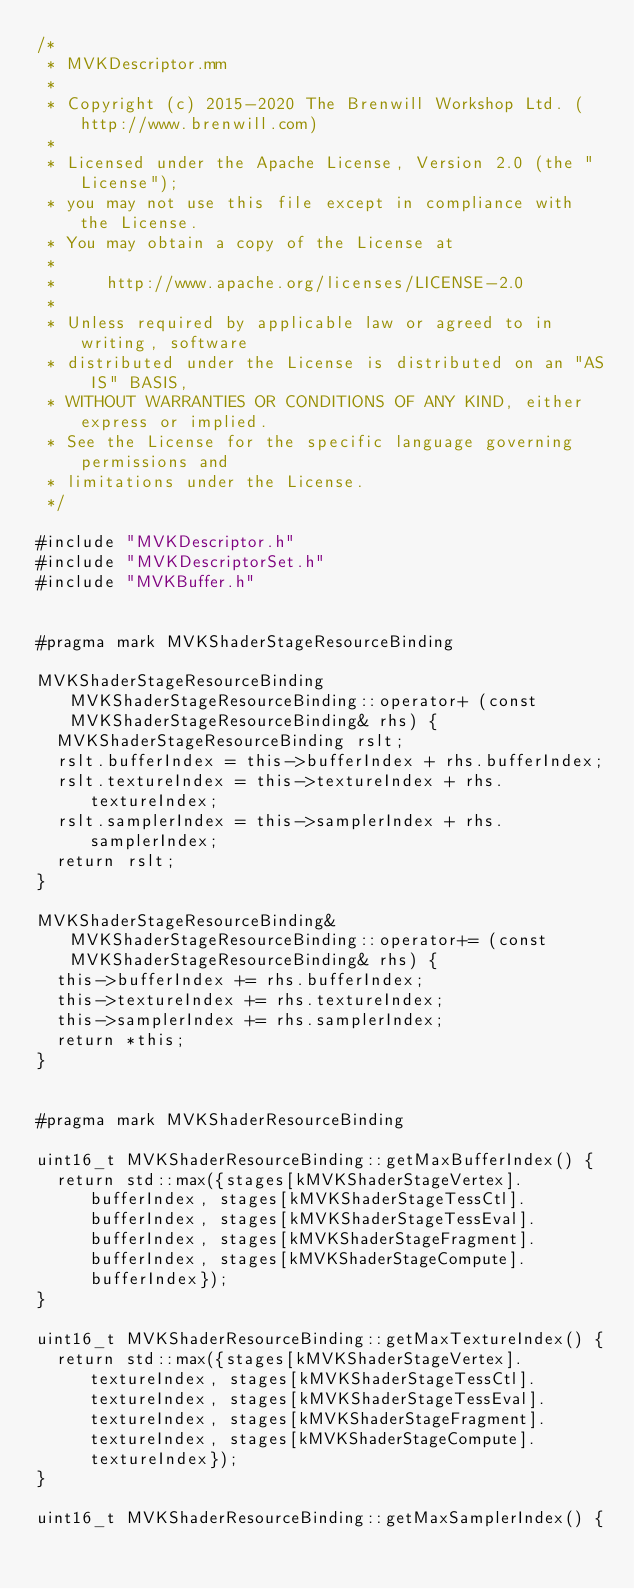Convert code to text. <code><loc_0><loc_0><loc_500><loc_500><_ObjectiveC_>/*
 * MVKDescriptor.mm
 *
 * Copyright (c) 2015-2020 The Brenwill Workshop Ltd. (http://www.brenwill.com)
 *
 * Licensed under the Apache License, Version 2.0 (the "License");
 * you may not use this file except in compliance with the License.
 * You may obtain a copy of the License at
 * 
 *     http://www.apache.org/licenses/LICENSE-2.0
 * 
 * Unless required by applicable law or agreed to in writing, software
 * distributed under the License is distributed on an "AS IS" BASIS,
 * WITHOUT WARRANTIES OR CONDITIONS OF ANY KIND, either express or implied.
 * See the License for the specific language governing permissions and
 * limitations under the License.
 */

#include "MVKDescriptor.h"
#include "MVKDescriptorSet.h"
#include "MVKBuffer.h"


#pragma mark MVKShaderStageResourceBinding

MVKShaderStageResourceBinding MVKShaderStageResourceBinding::operator+ (const MVKShaderStageResourceBinding& rhs) {
	MVKShaderStageResourceBinding rslt;
	rslt.bufferIndex = this->bufferIndex + rhs.bufferIndex;
	rslt.textureIndex = this->textureIndex + rhs.textureIndex;
	rslt.samplerIndex = this->samplerIndex + rhs.samplerIndex;
	return rslt;
}

MVKShaderStageResourceBinding& MVKShaderStageResourceBinding::operator+= (const MVKShaderStageResourceBinding& rhs) {
	this->bufferIndex += rhs.bufferIndex;
	this->textureIndex += rhs.textureIndex;
	this->samplerIndex += rhs.samplerIndex;
	return *this;
}


#pragma mark MVKShaderResourceBinding

uint16_t MVKShaderResourceBinding::getMaxBufferIndex() {
	return std::max({stages[kMVKShaderStageVertex].bufferIndex, stages[kMVKShaderStageTessCtl].bufferIndex, stages[kMVKShaderStageTessEval].bufferIndex, stages[kMVKShaderStageFragment].bufferIndex, stages[kMVKShaderStageCompute].bufferIndex});
}

uint16_t MVKShaderResourceBinding::getMaxTextureIndex() {
	return std::max({stages[kMVKShaderStageVertex].textureIndex, stages[kMVKShaderStageTessCtl].textureIndex, stages[kMVKShaderStageTessEval].textureIndex, stages[kMVKShaderStageFragment].textureIndex, stages[kMVKShaderStageCompute].textureIndex});
}

uint16_t MVKShaderResourceBinding::getMaxSamplerIndex() {</code> 